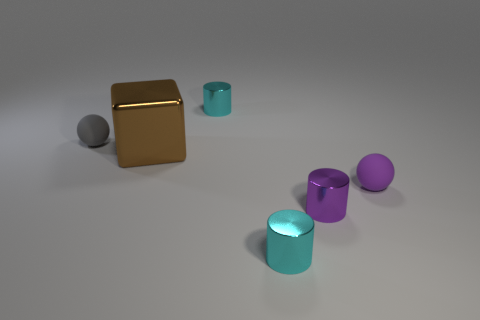What material is the tiny sphere to the right of the small cyan object that is in front of the shiny thing behind the brown cube?
Provide a short and direct response. Rubber. What is the color of the ball behind the purple sphere?
Provide a succinct answer. Gray. Is the number of metallic objects that are behind the big brown metal cube greater than the number of purple metal cylinders?
Make the answer very short. No. What number of other objects are the same size as the purple metallic object?
Keep it short and to the point. 4. How many small balls are in front of the large brown metal thing?
Your response must be concise. 1. Is the number of big shiny blocks behind the block the same as the number of objects behind the purple metallic cylinder?
Give a very brief answer. No. There is another object that is the same shape as the gray rubber object; what is its size?
Provide a succinct answer. Small. What shape is the tiny purple thing on the right side of the tiny purple cylinder?
Provide a succinct answer. Sphere. Do the sphere that is on the left side of the big block and the sphere that is to the right of the large brown cube have the same material?
Offer a very short reply. Yes. What is the shape of the big shiny thing?
Provide a short and direct response. Cube. 